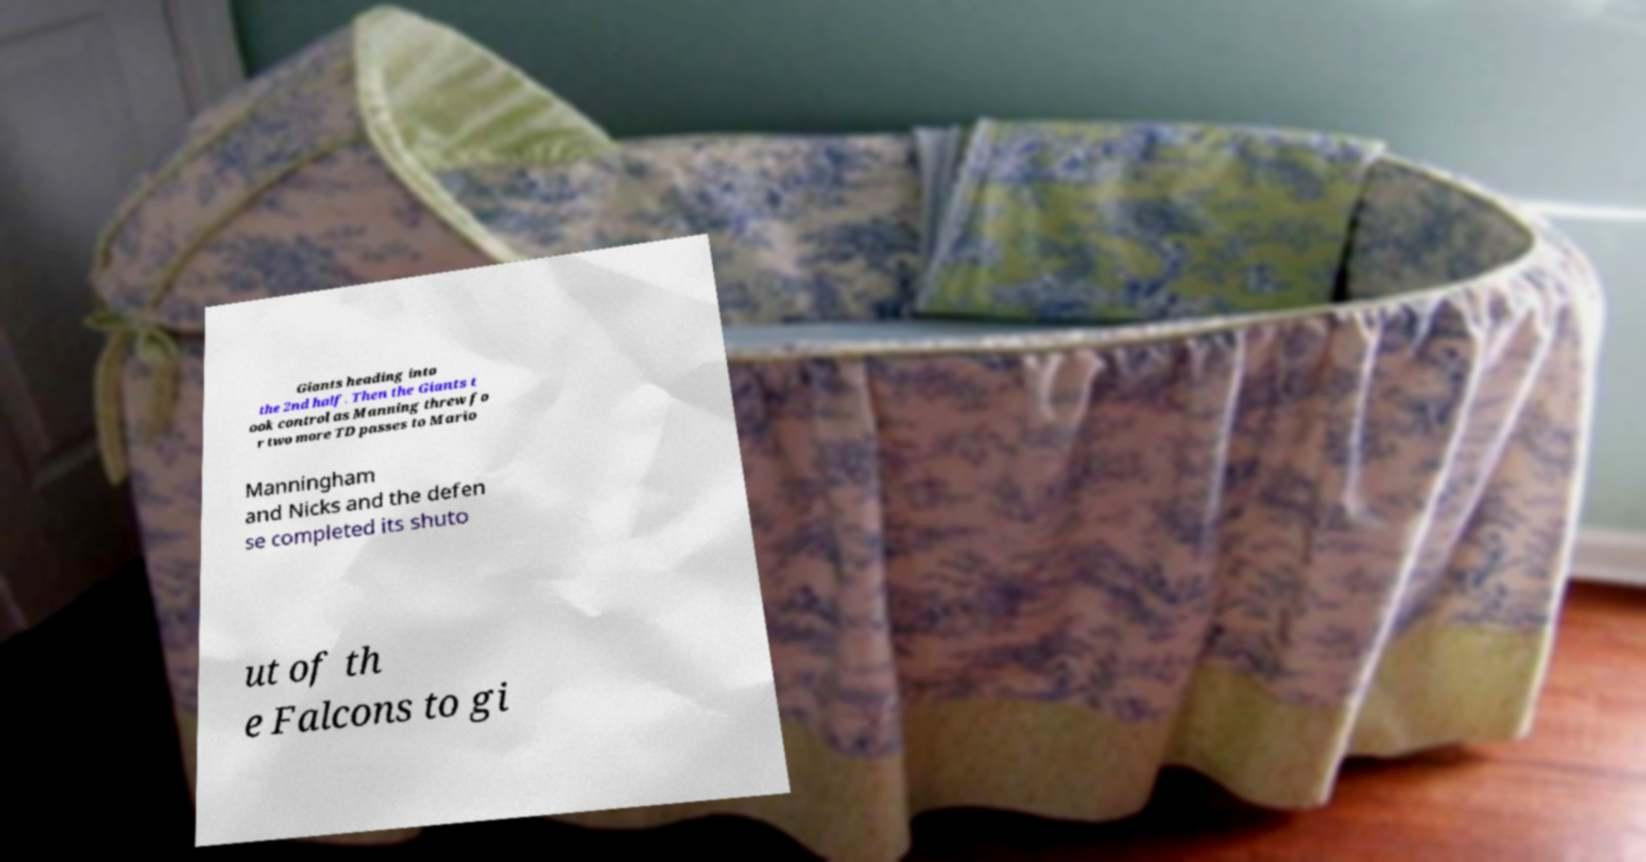I need the written content from this picture converted into text. Can you do that? Giants heading into the 2nd half. Then the Giants t ook control as Manning threw fo r two more TD passes to Mario Manningham and Nicks and the defen se completed its shuto ut of th e Falcons to gi 